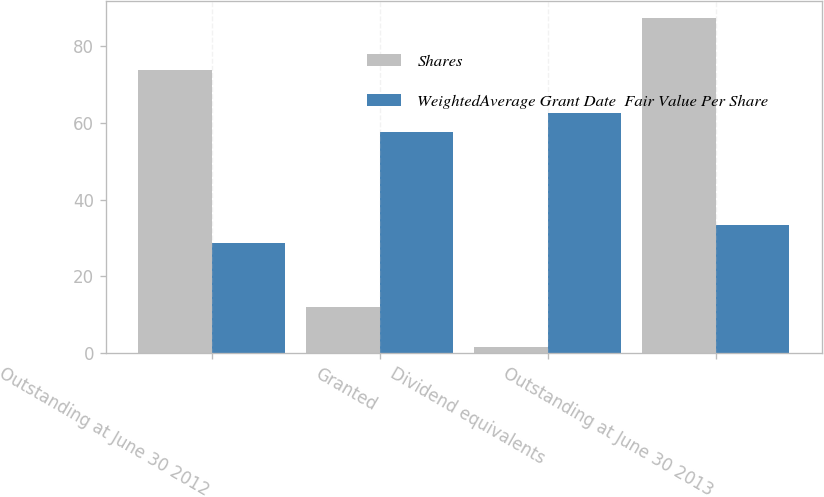<chart> <loc_0><loc_0><loc_500><loc_500><stacked_bar_chart><ecel><fcel>Outstanding at June 30 2012<fcel>Granted<fcel>Dividend equivalents<fcel>Outstanding at June 30 2013<nl><fcel>Shares<fcel>73.7<fcel>12.1<fcel>1.5<fcel>87.3<nl><fcel>WeightedAverage Grant Date  Fair Value Per Share<fcel>28.69<fcel>57.49<fcel>62.65<fcel>33.27<nl></chart> 